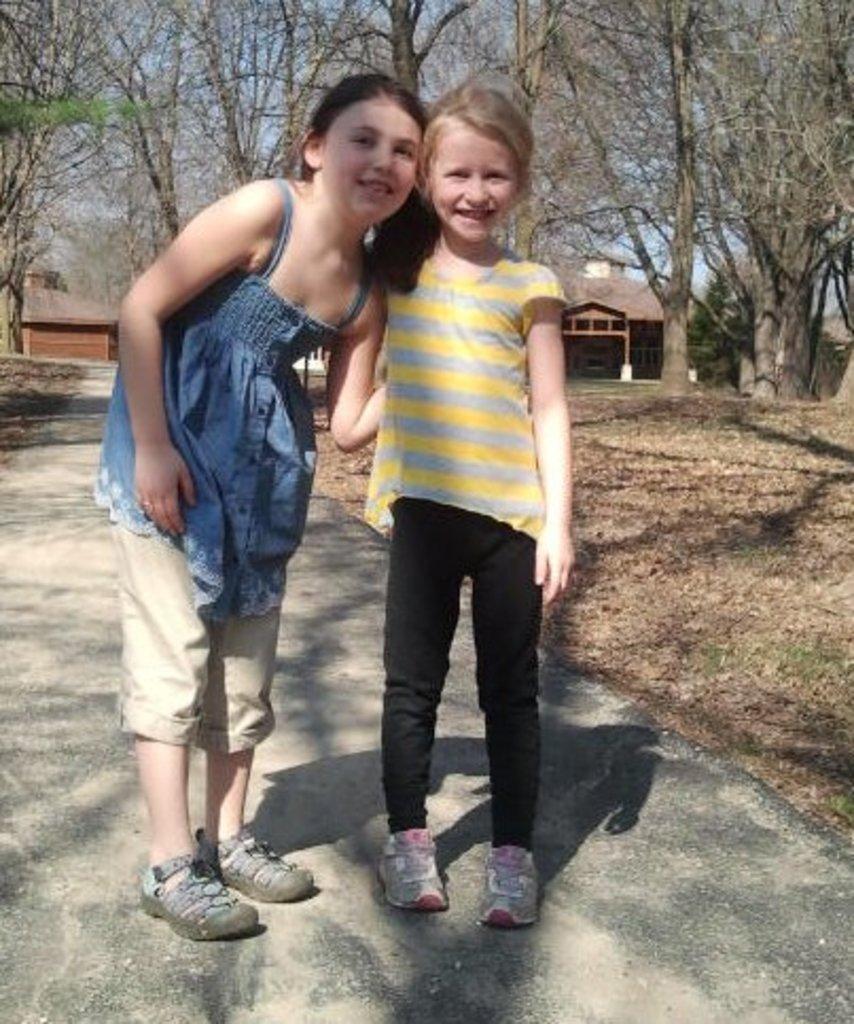Can you describe this image briefly? In this image I can see two kids. In the background I can see some buildings and trees. 